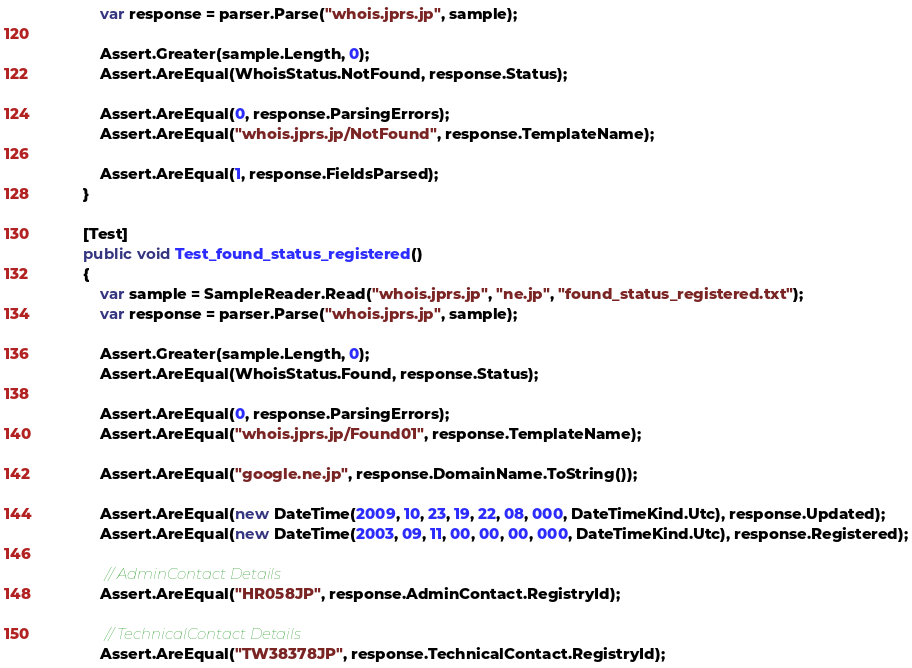<code> <loc_0><loc_0><loc_500><loc_500><_C#_>            var response = parser.Parse("whois.jprs.jp", sample);

            Assert.Greater(sample.Length, 0);
            Assert.AreEqual(WhoisStatus.NotFound, response.Status);

            Assert.AreEqual(0, response.ParsingErrors);
            Assert.AreEqual("whois.jprs.jp/NotFound", response.TemplateName);

            Assert.AreEqual(1, response.FieldsParsed);
        }

        [Test]
        public void Test_found_status_registered()
        {
            var sample = SampleReader.Read("whois.jprs.jp", "ne.jp", "found_status_registered.txt");
            var response = parser.Parse("whois.jprs.jp", sample);

            Assert.Greater(sample.Length, 0);
            Assert.AreEqual(WhoisStatus.Found, response.Status);

            Assert.AreEqual(0, response.ParsingErrors);
            Assert.AreEqual("whois.jprs.jp/Found01", response.TemplateName);

            Assert.AreEqual("google.ne.jp", response.DomainName.ToString());

            Assert.AreEqual(new DateTime(2009, 10, 23, 19, 22, 08, 000, DateTimeKind.Utc), response.Updated);
            Assert.AreEqual(new DateTime(2003, 09, 11, 00, 00, 00, 000, DateTimeKind.Utc), response.Registered);

             // AdminContact Details
            Assert.AreEqual("HR058JP", response.AdminContact.RegistryId);

             // TechnicalContact Details
            Assert.AreEqual("TW38378JP", response.TechnicalContact.RegistryId);
</code> 